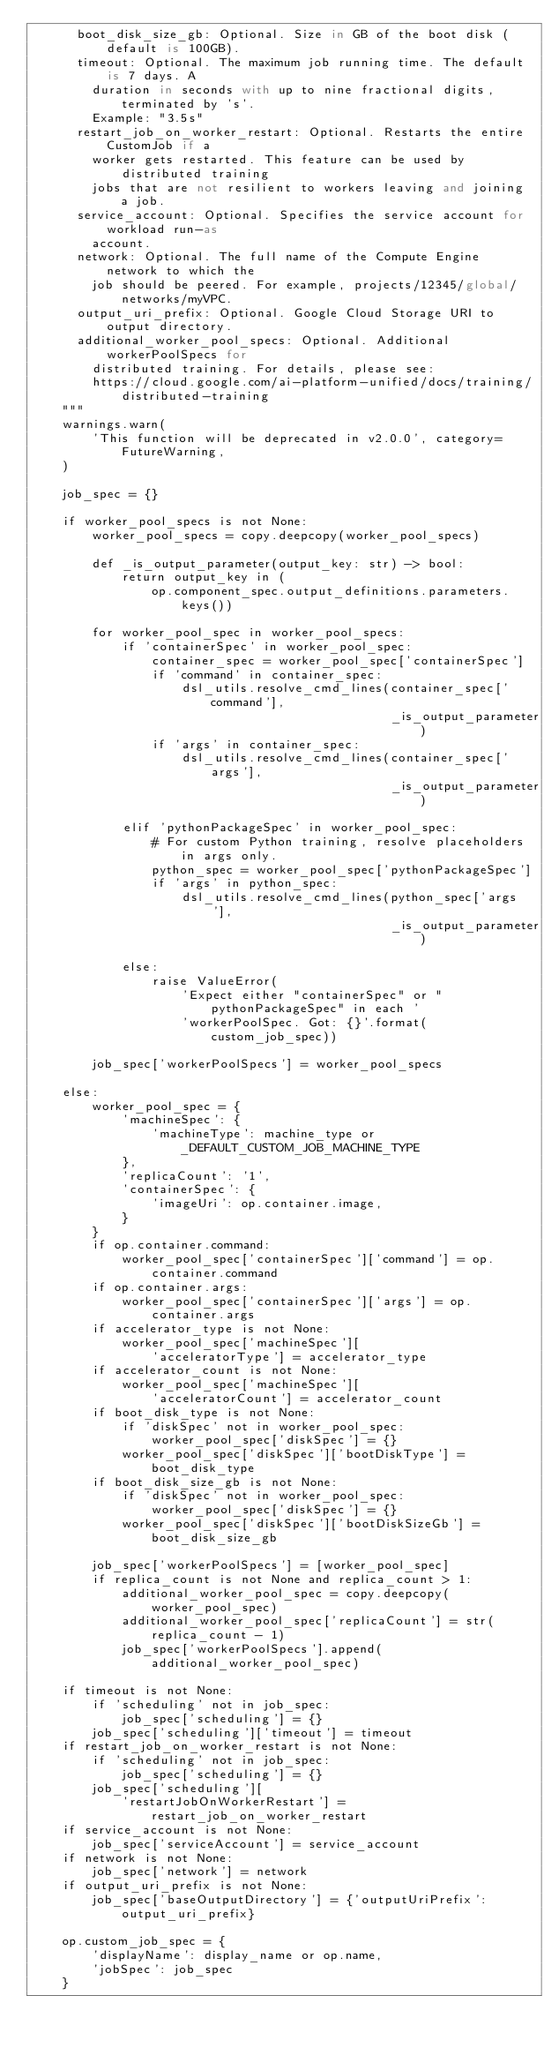<code> <loc_0><loc_0><loc_500><loc_500><_Python_>      boot_disk_size_gb: Optional. Size in GB of the boot disk (default is 100GB).
      timeout: Optional. The maximum job running time. The default is 7 days. A
        duration in seconds with up to nine fractional digits, terminated by 's'.
        Example: "3.5s"
      restart_job_on_worker_restart: Optional. Restarts the entire CustomJob if a
        worker gets restarted. This feature can be used by distributed training
        jobs that are not resilient to workers leaving and joining a job.
      service_account: Optional. Specifies the service account for workload run-as
        account.
      network: Optional. The full name of the Compute Engine network to which the
        job should be peered. For example, projects/12345/global/networks/myVPC.
      output_uri_prefix: Optional. Google Cloud Storage URI to output directory.
      additional_worker_pool_specs: Optional. Additional workerPoolSpecs for
        distributed training. For details, please see:
        https://cloud.google.com/ai-platform-unified/docs/training/distributed-training
    """
    warnings.warn(
        'This function will be deprecated in v2.0.0', category=FutureWarning,
    )

    job_spec = {}

    if worker_pool_specs is not None:
        worker_pool_specs = copy.deepcopy(worker_pool_specs)

        def _is_output_parameter(output_key: str) -> bool:
            return output_key in (
                op.component_spec.output_definitions.parameters.keys())

        for worker_pool_spec in worker_pool_specs:
            if 'containerSpec' in worker_pool_spec:
                container_spec = worker_pool_spec['containerSpec']
                if 'command' in container_spec:
                    dsl_utils.resolve_cmd_lines(container_spec['command'],
                                                _is_output_parameter)
                if 'args' in container_spec:
                    dsl_utils.resolve_cmd_lines(container_spec['args'],
                                                _is_output_parameter)

            elif 'pythonPackageSpec' in worker_pool_spec:
                # For custom Python training, resolve placeholders in args only.
                python_spec = worker_pool_spec['pythonPackageSpec']
                if 'args' in python_spec:
                    dsl_utils.resolve_cmd_lines(python_spec['args'],
                                                _is_output_parameter)

            else:
                raise ValueError(
                    'Expect either "containerSpec" or "pythonPackageSpec" in each '
                    'workerPoolSpec. Got: {}'.format(custom_job_spec))

        job_spec['workerPoolSpecs'] = worker_pool_specs

    else:
        worker_pool_spec = {
            'machineSpec': {
                'machineType': machine_type or _DEFAULT_CUSTOM_JOB_MACHINE_TYPE
            },
            'replicaCount': '1',
            'containerSpec': {
                'imageUri': op.container.image,
            }
        }
        if op.container.command:
            worker_pool_spec['containerSpec']['command'] = op.container.command
        if op.container.args:
            worker_pool_spec['containerSpec']['args'] = op.container.args
        if accelerator_type is not None:
            worker_pool_spec['machineSpec'][
                'acceleratorType'] = accelerator_type
        if accelerator_count is not None:
            worker_pool_spec['machineSpec'][
                'acceleratorCount'] = accelerator_count
        if boot_disk_type is not None:
            if 'diskSpec' not in worker_pool_spec:
                worker_pool_spec['diskSpec'] = {}
            worker_pool_spec['diskSpec']['bootDiskType'] = boot_disk_type
        if boot_disk_size_gb is not None:
            if 'diskSpec' not in worker_pool_spec:
                worker_pool_spec['diskSpec'] = {}
            worker_pool_spec['diskSpec']['bootDiskSizeGb'] = boot_disk_size_gb

        job_spec['workerPoolSpecs'] = [worker_pool_spec]
        if replica_count is not None and replica_count > 1:
            additional_worker_pool_spec = copy.deepcopy(worker_pool_spec)
            additional_worker_pool_spec['replicaCount'] = str(replica_count - 1)
            job_spec['workerPoolSpecs'].append(additional_worker_pool_spec)

    if timeout is not None:
        if 'scheduling' not in job_spec:
            job_spec['scheduling'] = {}
        job_spec['scheduling']['timeout'] = timeout
    if restart_job_on_worker_restart is not None:
        if 'scheduling' not in job_spec:
            job_spec['scheduling'] = {}
        job_spec['scheduling'][
            'restartJobOnWorkerRestart'] = restart_job_on_worker_restart
    if service_account is not None:
        job_spec['serviceAccount'] = service_account
    if network is not None:
        job_spec['network'] = network
    if output_uri_prefix is not None:
        job_spec['baseOutputDirectory'] = {'outputUriPrefix': output_uri_prefix}

    op.custom_job_spec = {
        'displayName': display_name or op.name,
        'jobSpec': job_spec
    }
</code> 